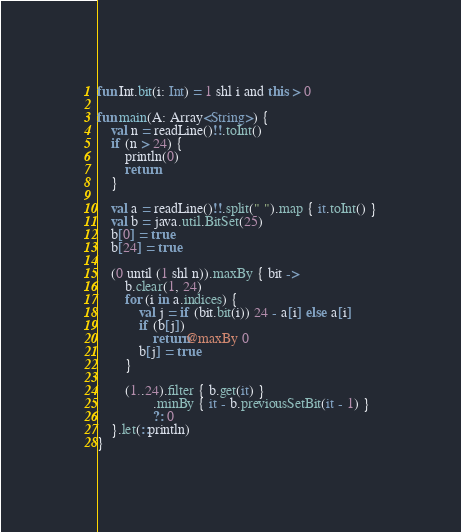<code> <loc_0><loc_0><loc_500><loc_500><_Kotlin_>fun Int.bit(i: Int) = 1 shl i and this > 0

fun main(A: Array<String>) {
    val n = readLine()!!.toInt()
    if (n > 24) {
        println(0)
        return
    }

    val a = readLine()!!.split(" ").map { it.toInt() }
    val b = java.util.BitSet(25)
    b[0] = true
    b[24] = true

    (0 until (1 shl n)).maxBy { bit ->
        b.clear(1, 24)
        for (i in a.indices) {
            val j = if (bit.bit(i)) 24 - a[i] else a[i]
            if (b[j])
                return@maxBy 0
            b[j] = true
        }

        (1..24).filter { b.get(it) }
                .minBy { it - b.previousSetBit(it - 1) }
                ?: 0
    }.let(::println)
}
</code> 